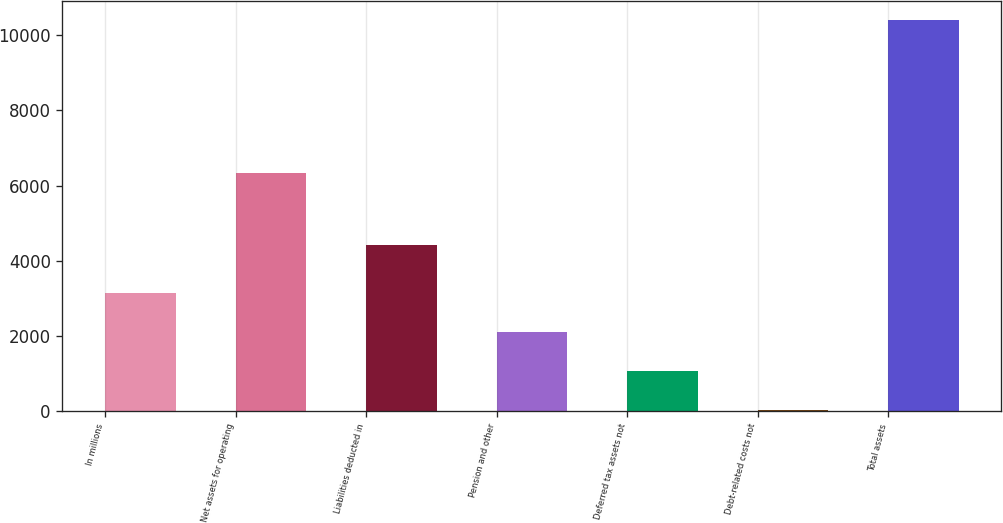Convert chart. <chart><loc_0><loc_0><loc_500><loc_500><bar_chart><fcel>In millions<fcel>Net assets for operating<fcel>Liabilities deducted in<fcel>Pension and other<fcel>Deferred tax assets not<fcel>Debt-related costs not<fcel>Total assets<nl><fcel>3138.1<fcel>6327<fcel>4412<fcel>2100.4<fcel>1062.7<fcel>25<fcel>10402<nl></chart> 